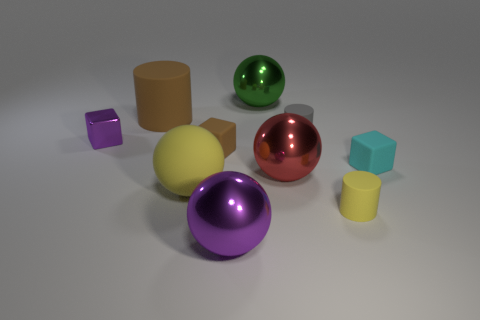Subtract all red balls. How many balls are left? 3 Subtract all blue spheres. Subtract all brown blocks. How many spheres are left? 4 Subtract all spheres. How many objects are left? 6 Subtract all cyan matte blocks. Subtract all matte cylinders. How many objects are left? 6 Add 6 matte cylinders. How many matte cylinders are left? 9 Add 2 gray rubber objects. How many gray rubber objects exist? 3 Subtract 1 brown cylinders. How many objects are left? 9 